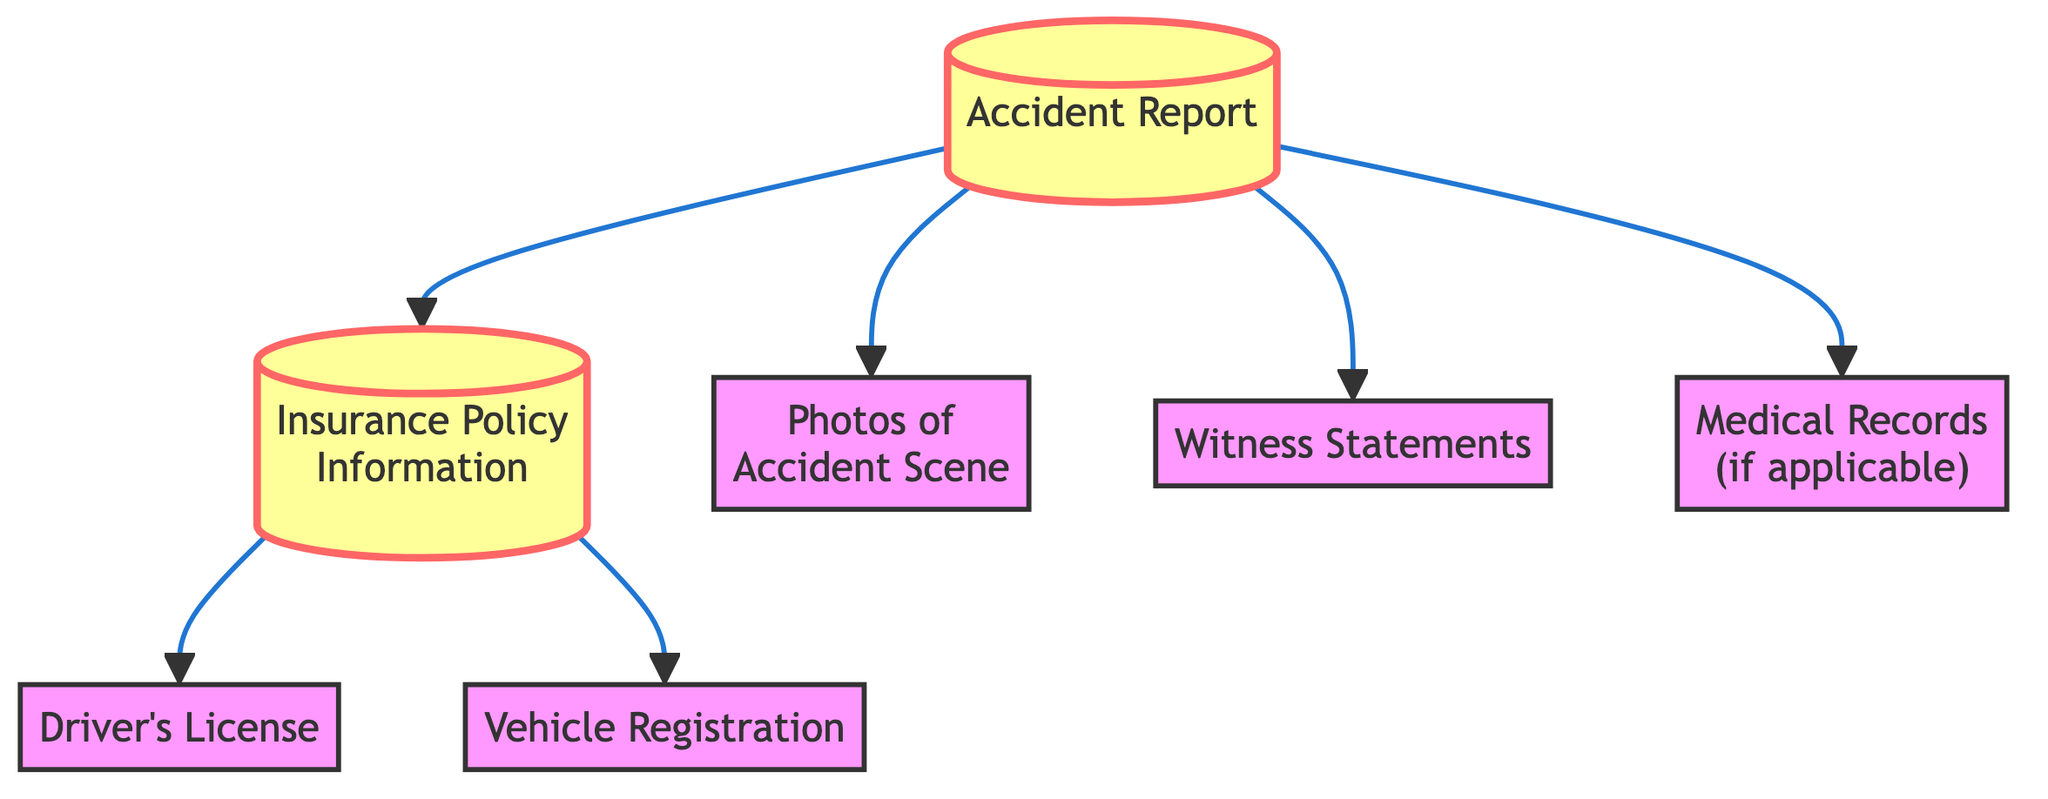What is the first document needed after an accident? The diagram shows that the first document needed is the "Accident Report" since it is connected to other necessary documents.
Answer: Accident Report How many nodes are there in the diagram? Counting all the unique documents listed, there are seven nodes including the accident report, insurance policy information, driver's license, vehicle registration, photos of the accident scene, witness statements, and medical records.
Answer: 7 What is the connection between the Insurance Policy Information and the Driver's License? There is a directed connection in the diagram from "Insurance Policy Information" to "Driver's License," indicating that the driver's license is needed after referencing the insurance policy information.
Answer: Driver's License Which document is connected directly to the Accident Report and requires a photo? The "Photos of the Accident Scene" is directly connected to the "Accident Report," indicating it is required as part of the claims process.
Answer: Photos of the Accident Scene How many documents are directly linked to the Accident Report? The diagram indicates that there are three documents that are directly connected to the "Accident Report": "Photos of the Accident Scene," "Witness Statements," and "Medical Records (if applicable)."
Answer: 3 What is the last document that requires the Insurance Policy Information? The last documents linked to "Insurance Policy Information" are the "Driver's License" and "Vehicle Registration." Therefore, both are required following the insurance details, but specifically, the "Vehicle Registration" is the last one provided in the flow.
Answer: Vehicle Registration Are Witness Statements required after the Accident Report? Yes, the diagram shows a direct connection from the "Accident Report" to "Witness Statements," indicating that witness statements are indeed required after the accident report.
Answer: Yes 